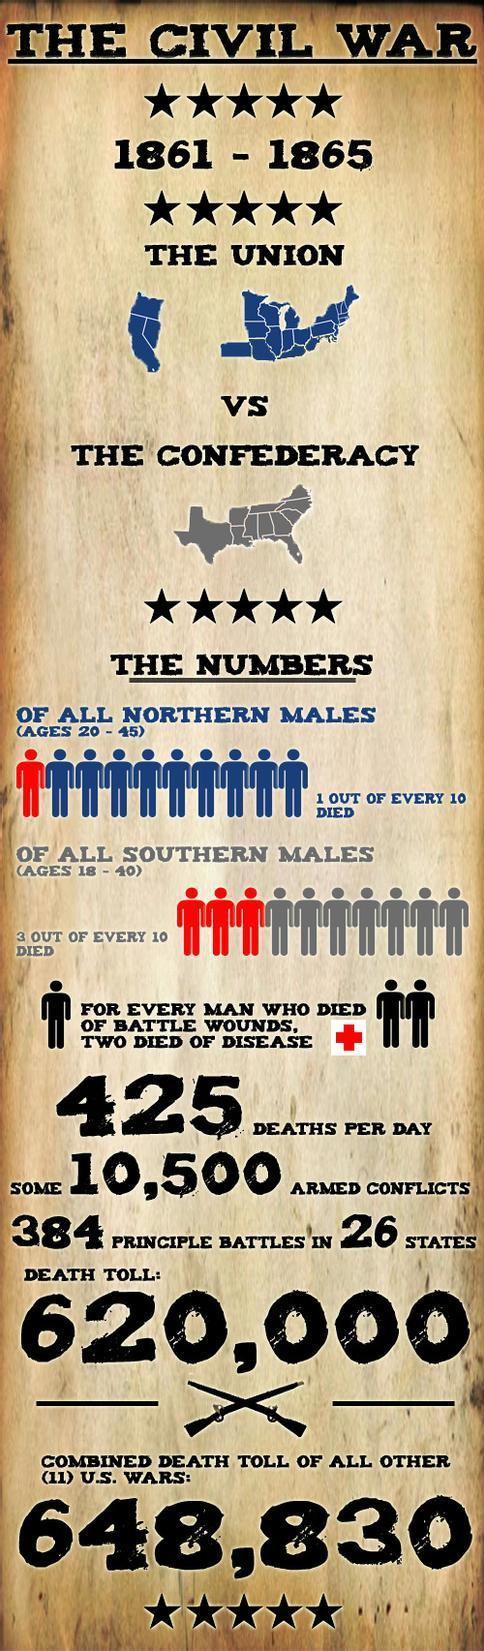When did the American civil war begin?
Answer the question with a short phrase. 1861 